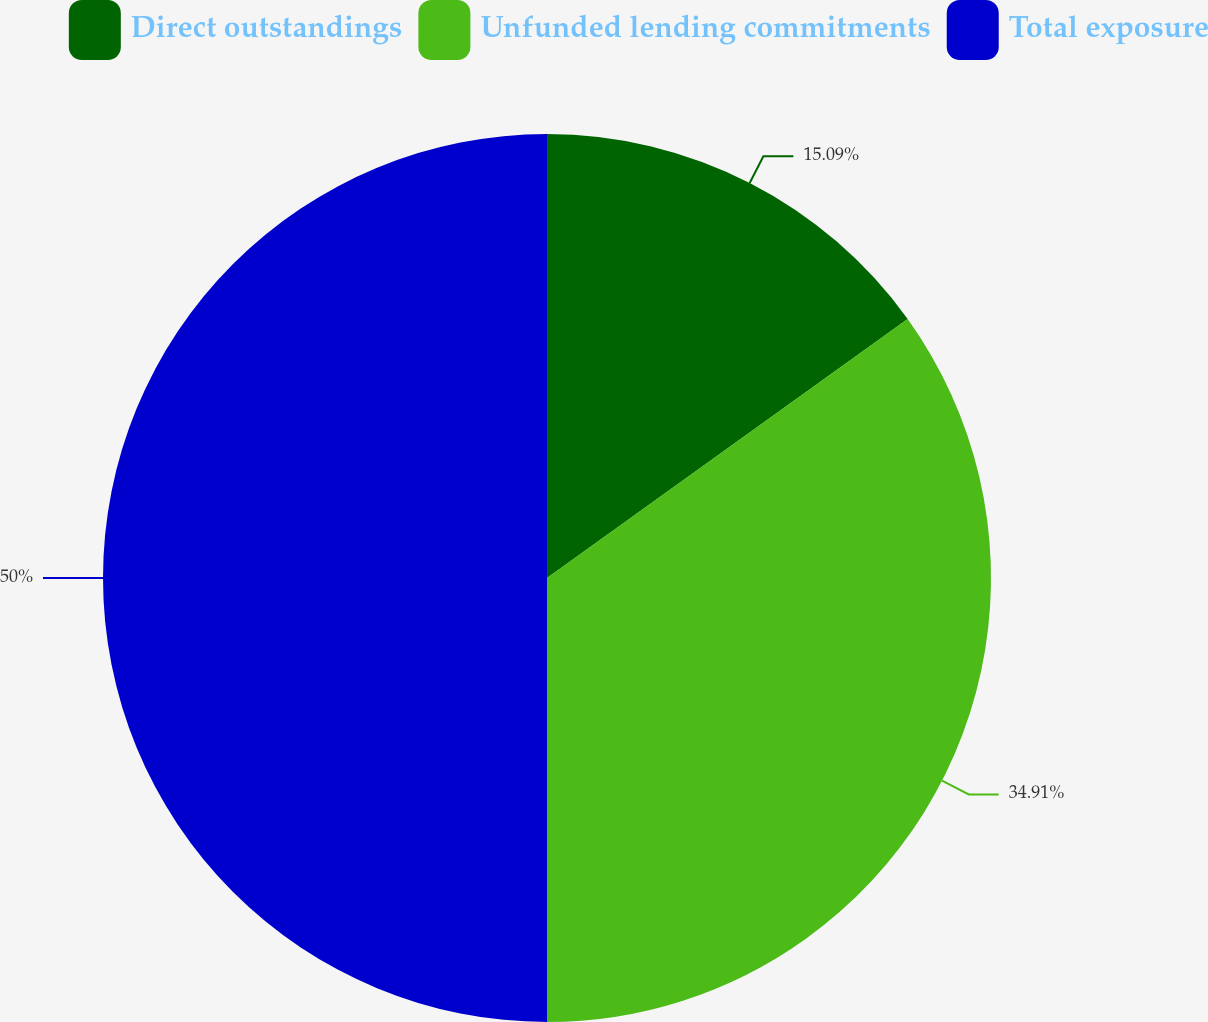<chart> <loc_0><loc_0><loc_500><loc_500><pie_chart><fcel>Direct outstandings<fcel>Unfunded lending commitments<fcel>Total exposure<nl><fcel>15.09%<fcel>34.91%<fcel>50.0%<nl></chart> 